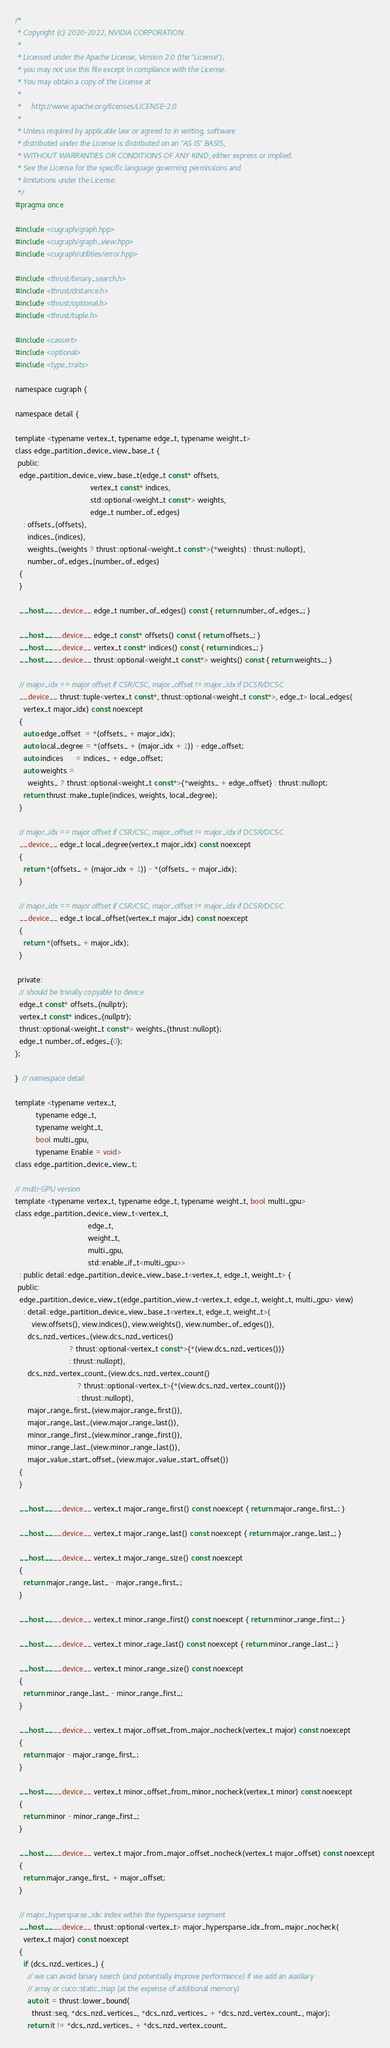<code> <loc_0><loc_0><loc_500><loc_500><_Cuda_>/*
 * Copyright (c) 2020-2022, NVIDIA CORPORATION.
 *
 * Licensed under the Apache License, Version 2.0 (the "License");
 * you may not use this file except in compliance with the License.
 * You may obtain a copy of the License at
 *
 *     http://www.apache.org/licenses/LICENSE-2.0
 *
 * Unless required by applicable law or agreed to in writing, software
 * distributed under the License is distributed on an "AS IS" BASIS,
 * WITHOUT WARRANTIES OR CONDITIONS OF ANY KIND, either express or implied.
 * See the License for the specific language governing permissions and
 * limitations under the License.
 */
#pragma once

#include <cugraph/graph.hpp>
#include <cugraph/graph_view.hpp>
#include <cugraph/utilities/error.hpp>

#include <thrust/binary_search.h>
#include <thrust/distance.h>
#include <thrust/optional.h>
#include <thrust/tuple.h>

#include <cassert>
#include <optional>
#include <type_traits>

namespace cugraph {

namespace detail {

template <typename vertex_t, typename edge_t, typename weight_t>
class edge_partition_device_view_base_t {
 public:
  edge_partition_device_view_base_t(edge_t const* offsets,
                                    vertex_t const* indices,
                                    std::optional<weight_t const*> weights,
                                    edge_t number_of_edges)
    : offsets_(offsets),
      indices_(indices),
      weights_(weights ? thrust::optional<weight_t const*>(*weights) : thrust::nullopt),
      number_of_edges_(number_of_edges)
  {
  }

  __host__ __device__ edge_t number_of_edges() const { return number_of_edges_; }

  __host__ __device__ edge_t const* offsets() const { return offsets_; }
  __host__ __device__ vertex_t const* indices() const { return indices_; }
  __host__ __device__ thrust::optional<weight_t const*> weights() const { return weights_; }

  // major_idx == major offset if CSR/CSC, major_offset != major_idx if DCSR/DCSC
  __device__ thrust::tuple<vertex_t const*, thrust::optional<weight_t const*>, edge_t> local_edges(
    vertex_t major_idx) const noexcept
  {
    auto edge_offset  = *(offsets_ + major_idx);
    auto local_degree = *(offsets_ + (major_idx + 1)) - edge_offset;
    auto indices      = indices_ + edge_offset;
    auto weights =
      weights_ ? thrust::optional<weight_t const*>{*weights_ + edge_offset} : thrust::nullopt;
    return thrust::make_tuple(indices, weights, local_degree);
  }

  // major_idx == major offset if CSR/CSC, major_offset != major_idx if DCSR/DCSC
  __device__ edge_t local_degree(vertex_t major_idx) const noexcept
  {
    return *(offsets_ + (major_idx + 1)) - *(offsets_ + major_idx);
  }

  // major_idx == major offset if CSR/CSC, major_offset != major_idx if DCSR/DCSC
  __device__ edge_t local_offset(vertex_t major_idx) const noexcept
  {
    return *(offsets_ + major_idx);
  }

 private:
  // should be trivially copyable to device
  edge_t const* offsets_{nullptr};
  vertex_t const* indices_{nullptr};
  thrust::optional<weight_t const*> weights_{thrust::nullopt};
  edge_t number_of_edges_{0};
};

}  // namespace detail

template <typename vertex_t,
          typename edge_t,
          typename weight_t,
          bool multi_gpu,
          typename Enable = void>
class edge_partition_device_view_t;

// multi-GPU version
template <typename vertex_t, typename edge_t, typename weight_t, bool multi_gpu>
class edge_partition_device_view_t<vertex_t,
                                   edge_t,
                                   weight_t,
                                   multi_gpu,
                                   std::enable_if_t<multi_gpu>>
  : public detail::edge_partition_device_view_base_t<vertex_t, edge_t, weight_t> {
 public:
  edge_partition_device_view_t(edge_partition_view_t<vertex_t, edge_t, weight_t, multi_gpu> view)
    : detail::edge_partition_device_view_base_t<vertex_t, edge_t, weight_t>(
        view.offsets(), view.indices(), view.weights(), view.number_of_edges()),
      dcs_nzd_vertices_(view.dcs_nzd_vertices()
                          ? thrust::optional<vertex_t const*>{*(view.dcs_nzd_vertices())}
                          : thrust::nullopt),
      dcs_nzd_vertex_count_(view.dcs_nzd_vertex_count()
                              ? thrust::optional<vertex_t>{*(view.dcs_nzd_vertex_count())}
                              : thrust::nullopt),
      major_range_first_(view.major_range_first()),
      major_range_last_(view.major_range_last()),
      minor_range_first_(view.minor_range_first()),
      minor_range_last_(view.minor_range_last()),
      major_value_start_offset_(view.major_value_start_offset())
  {
  }

  __host__ __device__ vertex_t major_range_first() const noexcept { return major_range_first_; }

  __host__ __device__ vertex_t major_range_last() const noexcept { return major_range_last_; }

  __host__ __device__ vertex_t major_range_size() const noexcept
  {
    return major_range_last_ - major_range_first_;
  }

  __host__ __device__ vertex_t minor_range_first() const noexcept { return minor_range_first_; }

  __host__ __device__ vertex_t minor_rage_last() const noexcept { return minor_range_last_; }

  __host__ __device__ vertex_t minor_range_size() const noexcept
  {
    return minor_range_last_ - minor_range_first_;
  }

  __host__ __device__ vertex_t major_offset_from_major_nocheck(vertex_t major) const noexcept
  {
    return major - major_range_first_;
  }

  __host__ __device__ vertex_t minor_offset_from_minor_nocheck(vertex_t minor) const noexcept
  {
    return minor - minor_range_first_;
  }

  __host__ __device__ vertex_t major_from_major_offset_nocheck(vertex_t major_offset) const noexcept
  {
    return major_range_first_ + major_offset;
  }

  // major_hypersparse_idx: index within the hypersparse segment
  __host__ __device__ thrust::optional<vertex_t> major_hypersparse_idx_from_major_nocheck(
    vertex_t major) const noexcept
  {
    if (dcs_nzd_vertices_) {
      // we can avoid binary search (and potentially improve performance) if we add an auxiliary
      // array or cuco::static_map (at the expense of additional memory)
      auto it = thrust::lower_bound(
        thrust::seq, *dcs_nzd_vertices_, *dcs_nzd_vertices_ + *dcs_nzd_vertex_count_, major);
      return it != *dcs_nzd_vertices_ + *dcs_nzd_vertex_count_</code> 